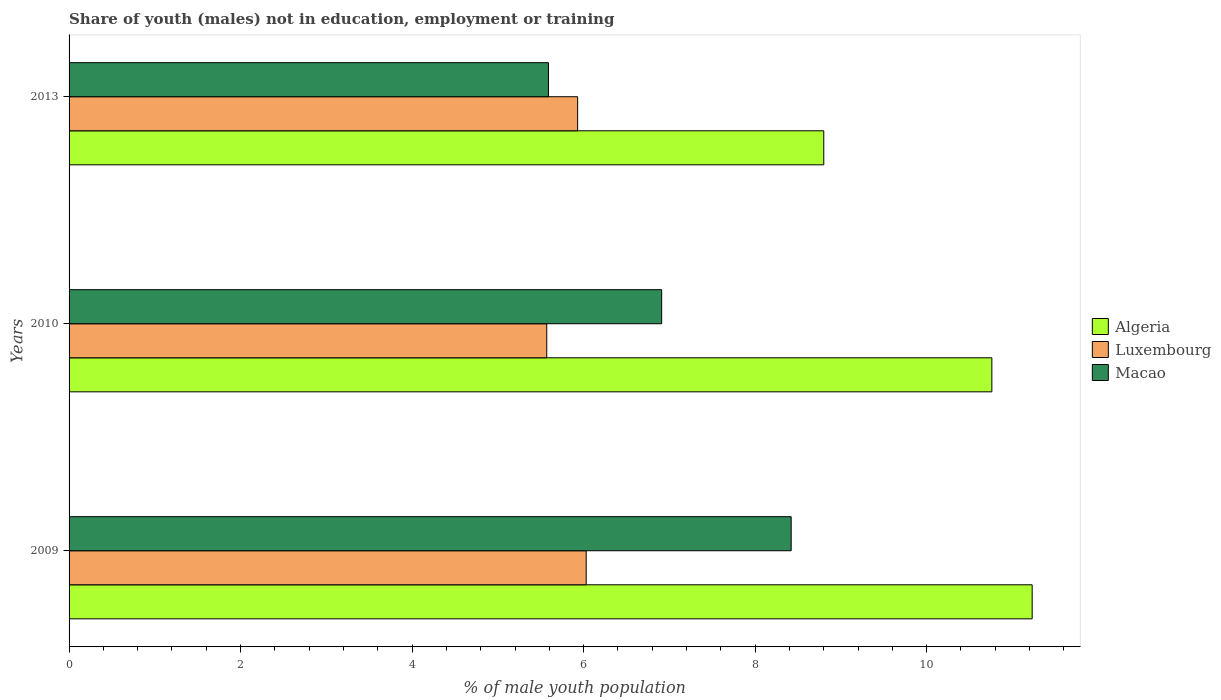Are the number of bars per tick equal to the number of legend labels?
Give a very brief answer. Yes. How many bars are there on the 1st tick from the bottom?
Offer a very short reply. 3. What is the label of the 2nd group of bars from the top?
Your response must be concise. 2010. In how many cases, is the number of bars for a given year not equal to the number of legend labels?
Your response must be concise. 0. What is the percentage of unemployed males population in in Algeria in 2013?
Your answer should be compact. 8.8. Across all years, what is the maximum percentage of unemployed males population in in Algeria?
Provide a succinct answer. 11.23. Across all years, what is the minimum percentage of unemployed males population in in Macao?
Make the answer very short. 5.59. What is the total percentage of unemployed males population in in Luxembourg in the graph?
Your answer should be compact. 17.53. What is the difference between the percentage of unemployed males population in in Algeria in 2009 and that in 2010?
Offer a very short reply. 0.47. What is the difference between the percentage of unemployed males population in in Algeria in 2010 and the percentage of unemployed males population in in Macao in 2009?
Keep it short and to the point. 2.34. What is the average percentage of unemployed males population in in Algeria per year?
Provide a succinct answer. 10.26. In the year 2009, what is the difference between the percentage of unemployed males population in in Macao and percentage of unemployed males population in in Algeria?
Ensure brevity in your answer.  -2.81. In how many years, is the percentage of unemployed males population in in Macao greater than 4 %?
Keep it short and to the point. 3. What is the ratio of the percentage of unemployed males population in in Luxembourg in 2009 to that in 2010?
Give a very brief answer. 1.08. What is the difference between the highest and the second highest percentage of unemployed males population in in Algeria?
Your answer should be compact. 0.47. What is the difference between the highest and the lowest percentage of unemployed males population in in Macao?
Provide a succinct answer. 2.83. In how many years, is the percentage of unemployed males population in in Macao greater than the average percentage of unemployed males population in in Macao taken over all years?
Offer a terse response. 1. What does the 1st bar from the top in 2013 represents?
Give a very brief answer. Macao. What does the 3rd bar from the bottom in 2010 represents?
Your answer should be very brief. Macao. What is the difference between two consecutive major ticks on the X-axis?
Offer a terse response. 2. Are the values on the major ticks of X-axis written in scientific E-notation?
Offer a terse response. No. Where does the legend appear in the graph?
Your answer should be compact. Center right. How many legend labels are there?
Provide a short and direct response. 3. What is the title of the graph?
Make the answer very short. Share of youth (males) not in education, employment or training. What is the label or title of the X-axis?
Offer a very short reply. % of male youth population. What is the % of male youth population in Algeria in 2009?
Your answer should be compact. 11.23. What is the % of male youth population of Luxembourg in 2009?
Ensure brevity in your answer.  6.03. What is the % of male youth population of Macao in 2009?
Give a very brief answer. 8.42. What is the % of male youth population in Algeria in 2010?
Your response must be concise. 10.76. What is the % of male youth population of Luxembourg in 2010?
Keep it short and to the point. 5.57. What is the % of male youth population of Macao in 2010?
Offer a very short reply. 6.91. What is the % of male youth population of Algeria in 2013?
Your answer should be compact. 8.8. What is the % of male youth population in Luxembourg in 2013?
Provide a succinct answer. 5.93. What is the % of male youth population in Macao in 2013?
Provide a short and direct response. 5.59. Across all years, what is the maximum % of male youth population in Algeria?
Your answer should be compact. 11.23. Across all years, what is the maximum % of male youth population of Luxembourg?
Your response must be concise. 6.03. Across all years, what is the maximum % of male youth population of Macao?
Your response must be concise. 8.42. Across all years, what is the minimum % of male youth population of Algeria?
Offer a very short reply. 8.8. Across all years, what is the minimum % of male youth population of Luxembourg?
Give a very brief answer. 5.57. Across all years, what is the minimum % of male youth population in Macao?
Provide a succinct answer. 5.59. What is the total % of male youth population in Algeria in the graph?
Provide a succinct answer. 30.79. What is the total % of male youth population in Luxembourg in the graph?
Offer a very short reply. 17.53. What is the total % of male youth population in Macao in the graph?
Your response must be concise. 20.92. What is the difference between the % of male youth population in Algeria in 2009 and that in 2010?
Give a very brief answer. 0.47. What is the difference between the % of male youth population in Luxembourg in 2009 and that in 2010?
Provide a short and direct response. 0.46. What is the difference between the % of male youth population in Macao in 2009 and that in 2010?
Your answer should be very brief. 1.51. What is the difference between the % of male youth population in Algeria in 2009 and that in 2013?
Provide a short and direct response. 2.43. What is the difference between the % of male youth population of Macao in 2009 and that in 2013?
Give a very brief answer. 2.83. What is the difference between the % of male youth population of Algeria in 2010 and that in 2013?
Offer a terse response. 1.96. What is the difference between the % of male youth population in Luxembourg in 2010 and that in 2013?
Provide a short and direct response. -0.36. What is the difference between the % of male youth population in Macao in 2010 and that in 2013?
Your response must be concise. 1.32. What is the difference between the % of male youth population in Algeria in 2009 and the % of male youth population in Luxembourg in 2010?
Your response must be concise. 5.66. What is the difference between the % of male youth population of Algeria in 2009 and the % of male youth population of Macao in 2010?
Your answer should be very brief. 4.32. What is the difference between the % of male youth population of Luxembourg in 2009 and the % of male youth population of Macao in 2010?
Provide a short and direct response. -0.88. What is the difference between the % of male youth population in Algeria in 2009 and the % of male youth population in Macao in 2013?
Your answer should be compact. 5.64. What is the difference between the % of male youth population in Luxembourg in 2009 and the % of male youth population in Macao in 2013?
Your answer should be very brief. 0.44. What is the difference between the % of male youth population of Algeria in 2010 and the % of male youth population of Luxembourg in 2013?
Offer a very short reply. 4.83. What is the difference between the % of male youth population of Algeria in 2010 and the % of male youth population of Macao in 2013?
Give a very brief answer. 5.17. What is the difference between the % of male youth population in Luxembourg in 2010 and the % of male youth population in Macao in 2013?
Give a very brief answer. -0.02. What is the average % of male youth population of Algeria per year?
Your response must be concise. 10.26. What is the average % of male youth population in Luxembourg per year?
Give a very brief answer. 5.84. What is the average % of male youth population in Macao per year?
Your answer should be compact. 6.97. In the year 2009, what is the difference between the % of male youth population of Algeria and % of male youth population of Macao?
Your answer should be very brief. 2.81. In the year 2009, what is the difference between the % of male youth population in Luxembourg and % of male youth population in Macao?
Your answer should be compact. -2.39. In the year 2010, what is the difference between the % of male youth population in Algeria and % of male youth population in Luxembourg?
Offer a very short reply. 5.19. In the year 2010, what is the difference between the % of male youth population in Algeria and % of male youth population in Macao?
Offer a terse response. 3.85. In the year 2010, what is the difference between the % of male youth population of Luxembourg and % of male youth population of Macao?
Provide a succinct answer. -1.34. In the year 2013, what is the difference between the % of male youth population of Algeria and % of male youth population of Luxembourg?
Make the answer very short. 2.87. In the year 2013, what is the difference between the % of male youth population of Algeria and % of male youth population of Macao?
Make the answer very short. 3.21. In the year 2013, what is the difference between the % of male youth population in Luxembourg and % of male youth population in Macao?
Your answer should be very brief. 0.34. What is the ratio of the % of male youth population of Algeria in 2009 to that in 2010?
Offer a terse response. 1.04. What is the ratio of the % of male youth population of Luxembourg in 2009 to that in 2010?
Provide a short and direct response. 1.08. What is the ratio of the % of male youth population in Macao in 2009 to that in 2010?
Ensure brevity in your answer.  1.22. What is the ratio of the % of male youth population of Algeria in 2009 to that in 2013?
Your response must be concise. 1.28. What is the ratio of the % of male youth population of Luxembourg in 2009 to that in 2013?
Provide a short and direct response. 1.02. What is the ratio of the % of male youth population of Macao in 2009 to that in 2013?
Give a very brief answer. 1.51. What is the ratio of the % of male youth population in Algeria in 2010 to that in 2013?
Provide a succinct answer. 1.22. What is the ratio of the % of male youth population in Luxembourg in 2010 to that in 2013?
Give a very brief answer. 0.94. What is the ratio of the % of male youth population in Macao in 2010 to that in 2013?
Keep it short and to the point. 1.24. What is the difference between the highest and the second highest % of male youth population of Algeria?
Offer a very short reply. 0.47. What is the difference between the highest and the second highest % of male youth population of Macao?
Offer a terse response. 1.51. What is the difference between the highest and the lowest % of male youth population in Algeria?
Give a very brief answer. 2.43. What is the difference between the highest and the lowest % of male youth population in Luxembourg?
Offer a terse response. 0.46. What is the difference between the highest and the lowest % of male youth population in Macao?
Your answer should be compact. 2.83. 